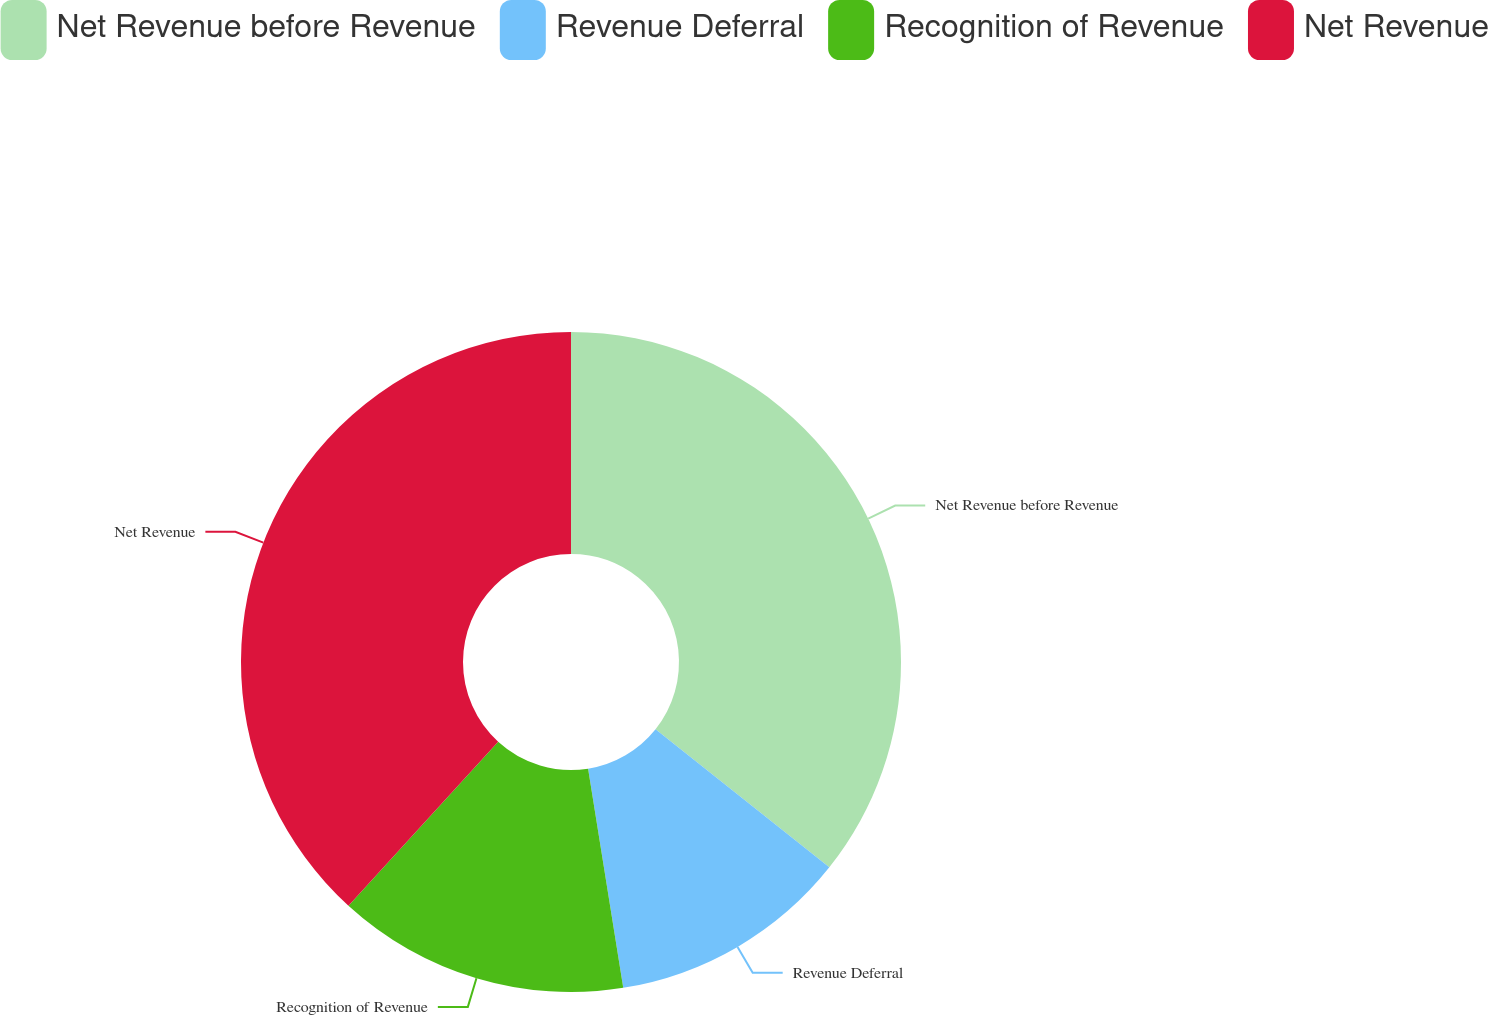<chart> <loc_0><loc_0><loc_500><loc_500><pie_chart><fcel>Net Revenue before Revenue<fcel>Revenue Deferral<fcel>Recognition of Revenue<fcel>Net Revenue<nl><fcel>35.69%<fcel>11.78%<fcel>14.31%<fcel>38.22%<nl></chart> 